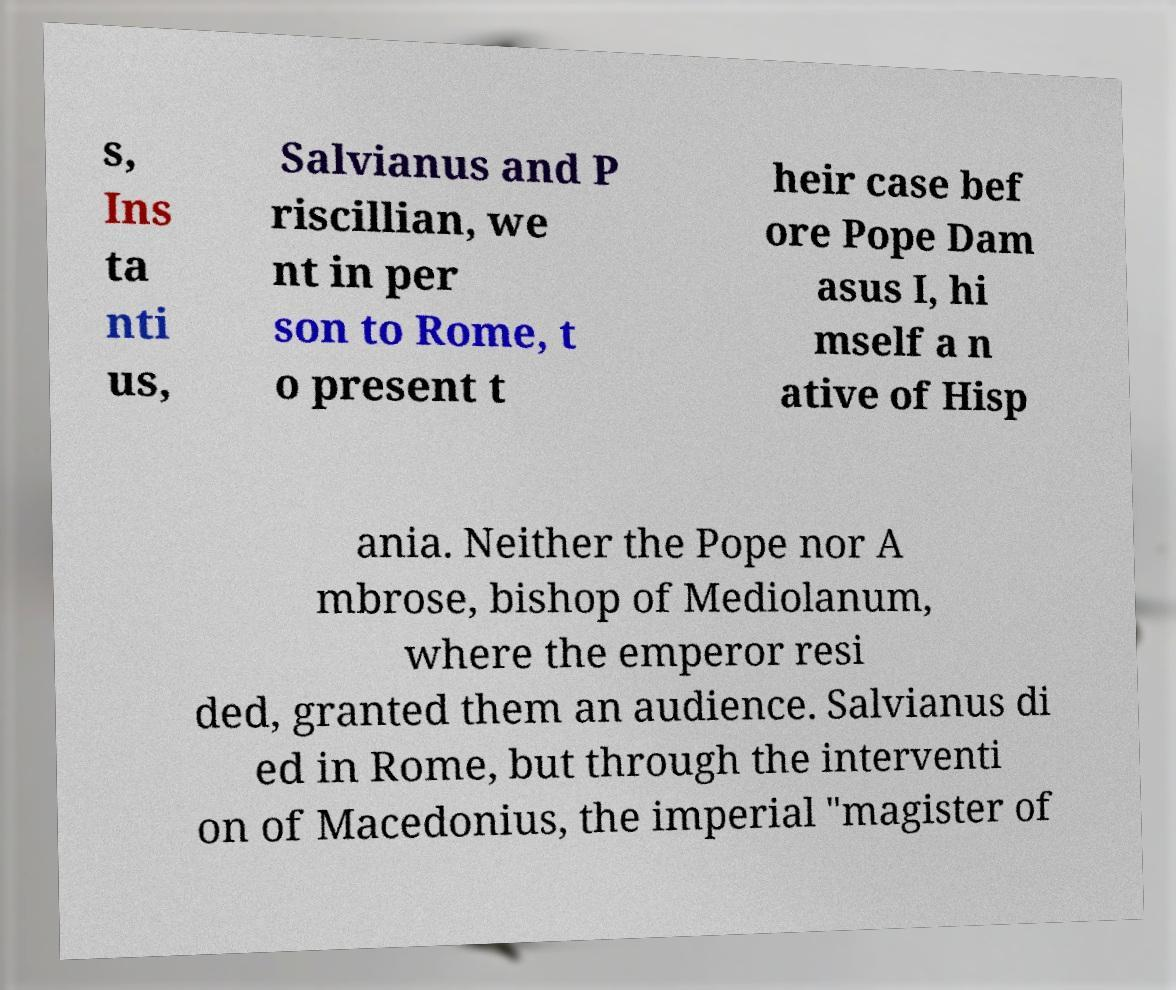Please read and relay the text visible in this image. What does it say? s, Ins ta nti us, Salvianus and P riscillian, we nt in per son to Rome, t o present t heir case bef ore Pope Dam asus I, hi mself a n ative of Hisp ania. Neither the Pope nor A mbrose, bishop of Mediolanum, where the emperor resi ded, granted them an audience. Salvianus di ed in Rome, but through the interventi on of Macedonius, the imperial "magister of 